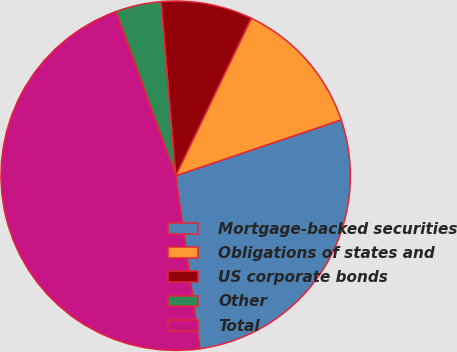Convert chart. <chart><loc_0><loc_0><loc_500><loc_500><pie_chart><fcel>Mortgage-backed securities<fcel>Obligations of states and<fcel>US corporate bonds<fcel>Other<fcel>Total<nl><fcel>27.97%<fcel>12.7%<fcel>8.46%<fcel>4.21%<fcel>46.66%<nl></chart> 